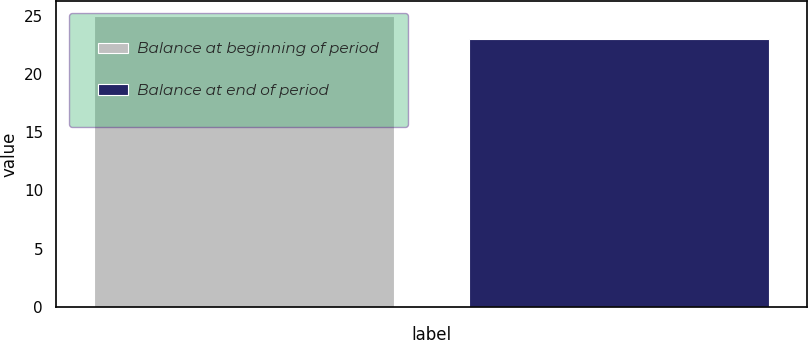<chart> <loc_0><loc_0><loc_500><loc_500><bar_chart><fcel>Balance at beginning of period<fcel>Balance at end of period<nl><fcel>25<fcel>23<nl></chart> 